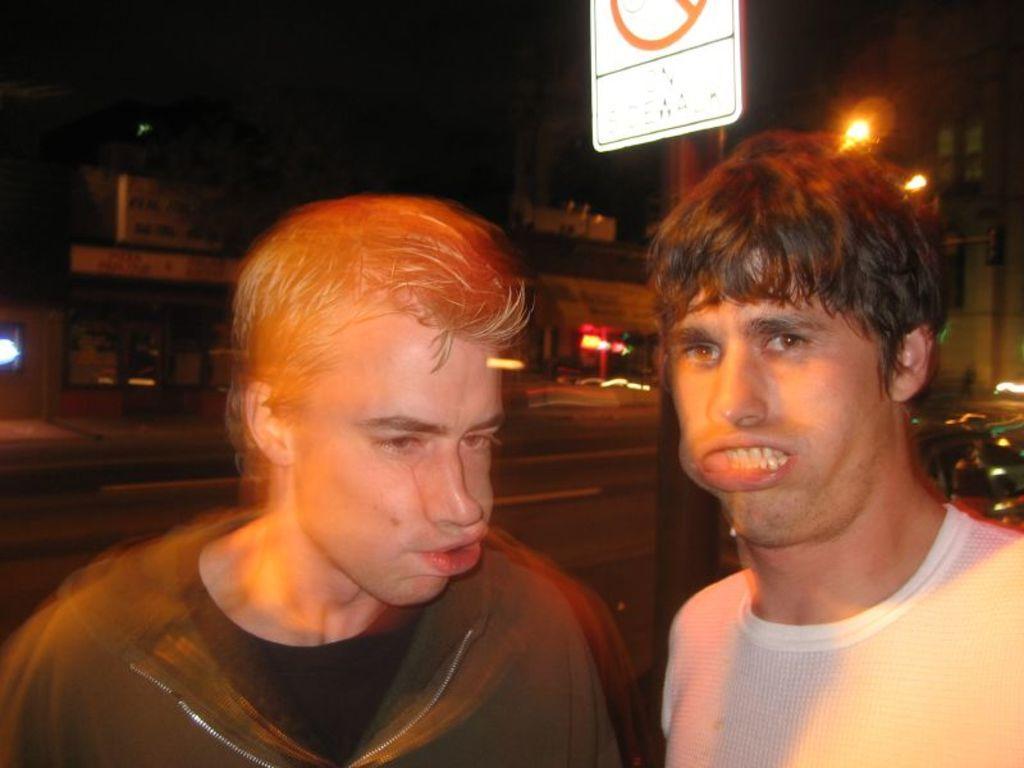Can you describe this image briefly? In the given image i can see a people,pole and in the background i can see a lights and houses. 